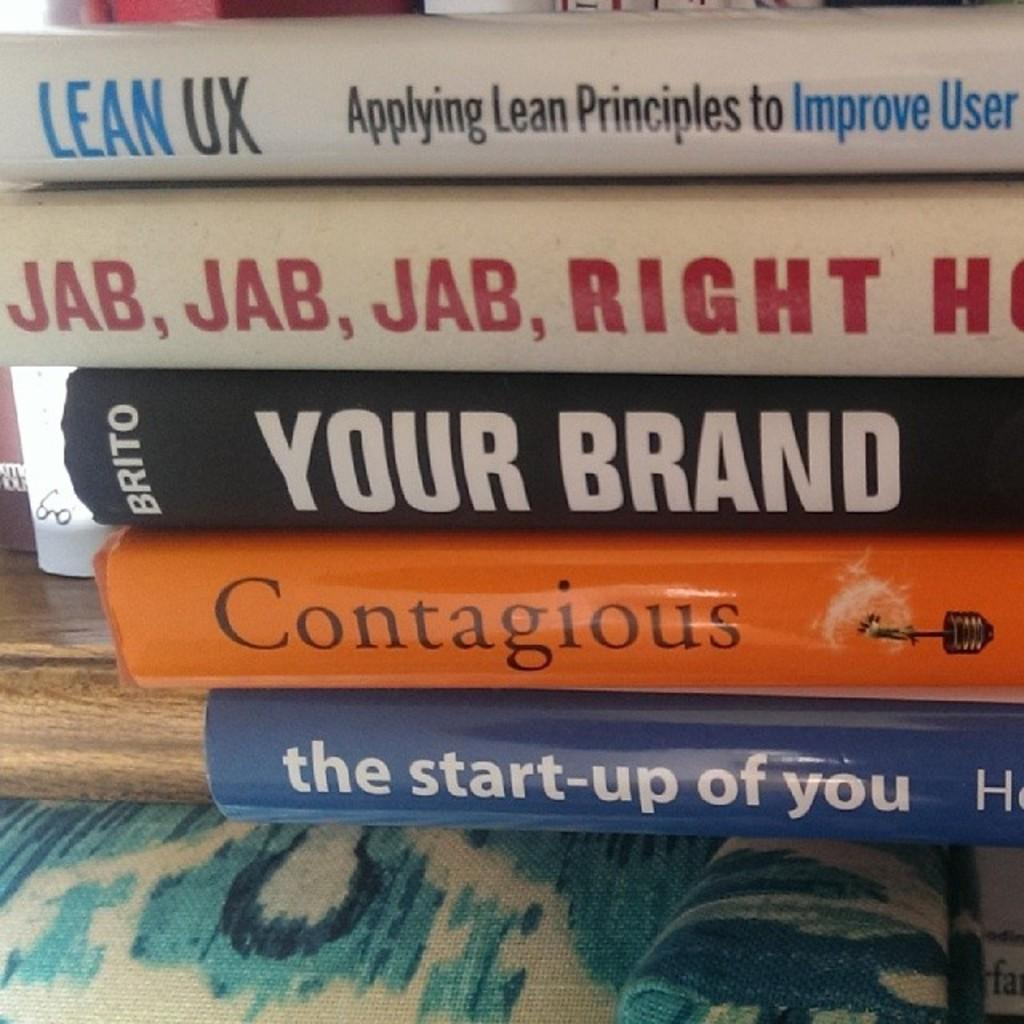<image>
Relay a brief, clear account of the picture shown. A stack of books that includes Contagious and the start up of you. 